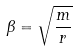Convert formula to latex. <formula><loc_0><loc_0><loc_500><loc_500>\beta = \sqrt { \frac { m } { r } }</formula> 